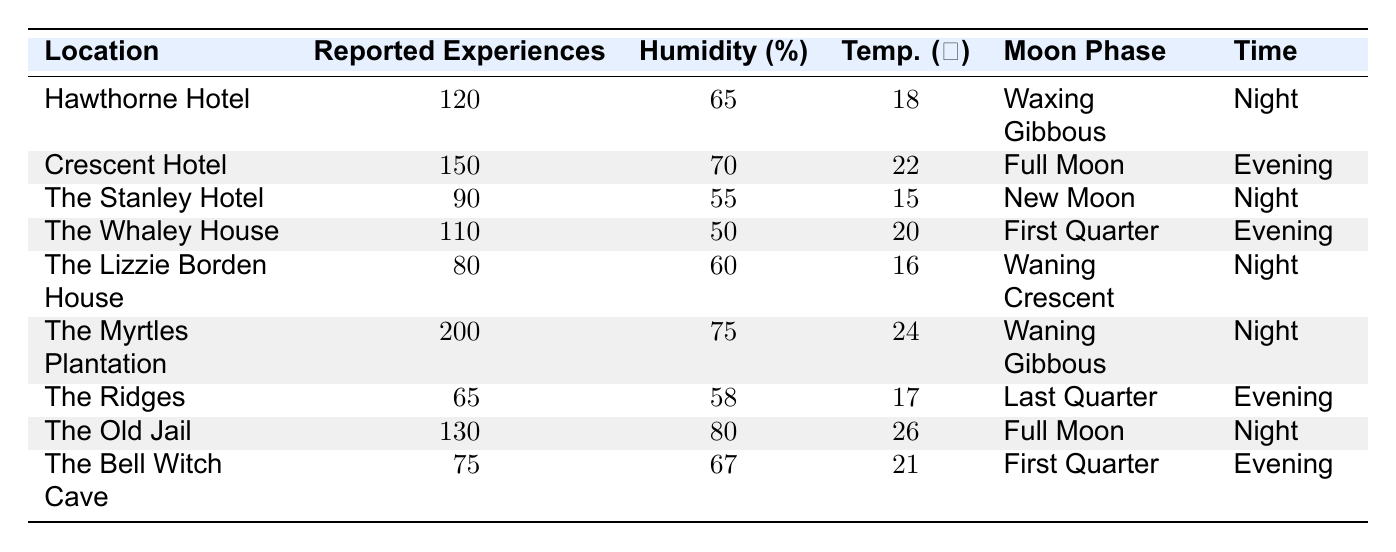What location reported the highest number of paranormal experiences? By looking at the table, the location with the highest reported experiences is The Myrtles Plantation, which has 200 reported experiences.
Answer: The Myrtles Plantation What is the temperature at The Old Jail? The table indicates that The Old Jail has a temperature of 26 degrees Celsius.
Answer: 26 How many reported experiences were noted at The Ridges? The Ridges had 65 reported experiences according to the table.
Answer: 65 Is the reported experience at The Bell Witch Cave higher than that at The Lizzie Borden House? The Bell Witch Cave reported 75 experiences, while The Lizzie Borden House reported 80 experiences. Since 75 is less than 80, the statement is false.
Answer: No What is the average humidity percentage of all locations listed? To find the average humidity, sum all the humidity percentages: 65 + 70 + 55 + 50 + 60 + 75 + 58 + 80 + 67 =  70. The total number of locations is 9, so the average humidity is 630/9, which equals approximately 70%.
Answer: 70 Did any locations report experiences during the 'Night' time? Yes, several locations reported experiences during the 'Night' time, specifically Hawthorne Hotel, The Stanley Hotel, The Myrtles Plantation, The Old Jail, and The Lizzie Borden House, which indicates that the statement is true.
Answer: Yes What is the difference in reported experiences between the Crescent Hotel and The Ridges? The Crescent Hotel reported 150 experiences while The Ridges reported 65 experiences. The difference is 150 - 65 = 85.
Answer: 85 How many locations had a humidity percentage above 70%? By examining the table, the locations with humidity above 70% are Crescent Hotel (70%), The Myrtles Plantation (75%), and The Old Jail (80%). Three locations have humidity above 70%.
Answer: 3 What was the moon phase at the location with the fewest reported experiences? The location with the fewest reported experiences is The Ridges, which had a Last Quarter moon phase.
Answer: Last Quarter Which moon phase was associated with the highest number of reported experiences? The Myrtles Plantation and Crescent Hotel are both associated with moon phases that had high reports. The Myrtles Plantation (Waning Gibbous) had the highest with 200 experiences, while the Crescent Hotel (Full Moon) reported 150. Therefore, the highest was during the Waning Gibbous phase.
Answer: Waning Gibbous 